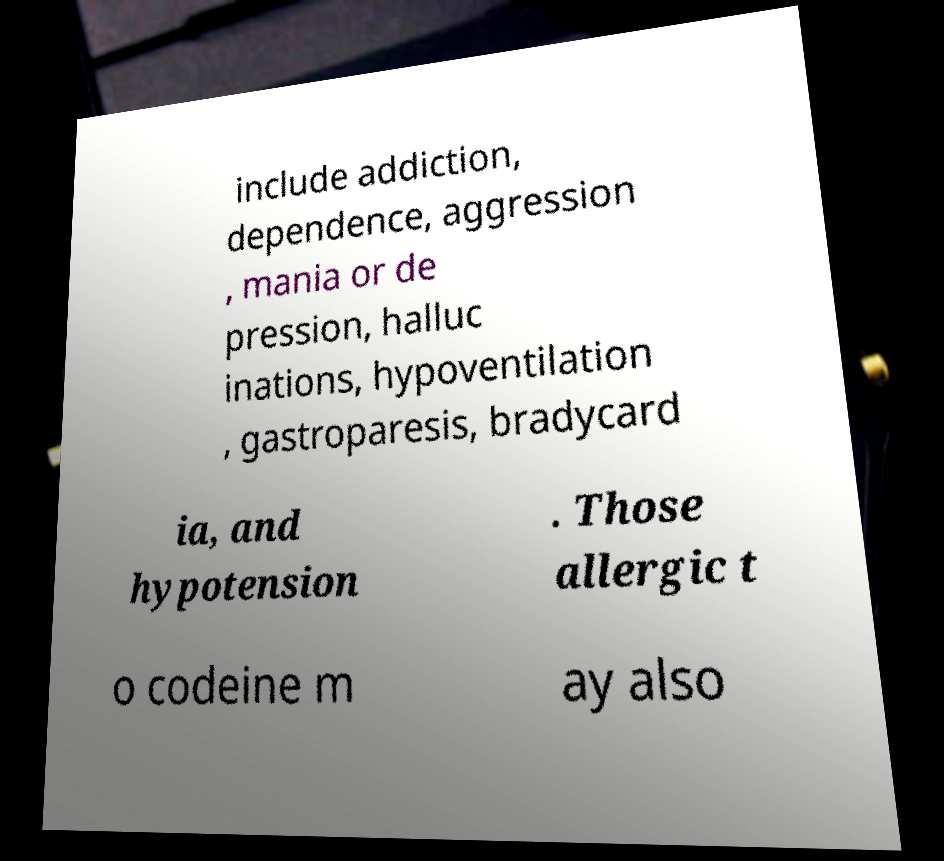There's text embedded in this image that I need extracted. Can you transcribe it verbatim? include addiction, dependence, aggression , mania or de pression, halluc inations, hypoventilation , gastroparesis, bradycard ia, and hypotension . Those allergic t o codeine m ay also 